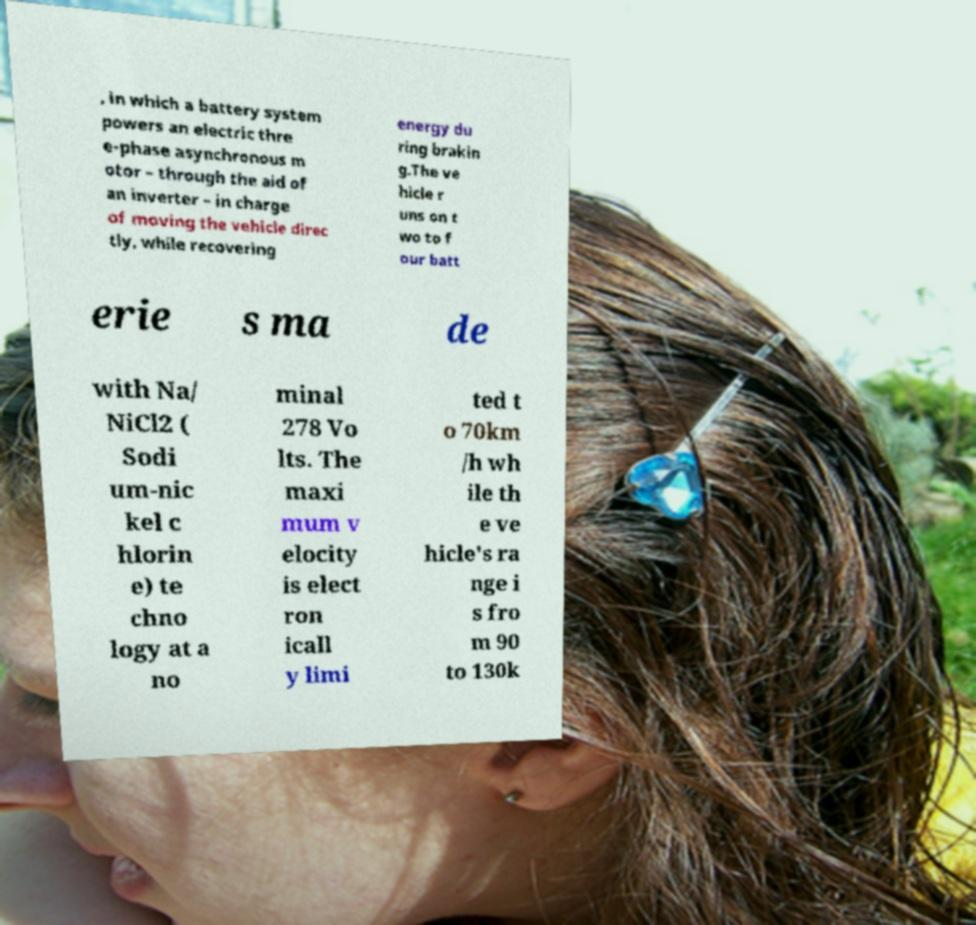There's text embedded in this image that I need extracted. Can you transcribe it verbatim? , in which a battery system powers an electric thre e-phase asynchronous m otor – through the aid of an inverter – in charge of moving the vehicle direc tly, while recovering energy du ring brakin g.The ve hicle r uns on t wo to f our batt erie s ma de with Na/ NiCl2 ( Sodi um-nic kel c hlorin e) te chno logy at a no minal 278 Vo lts. The maxi mum v elocity is elect ron icall y limi ted t o 70km /h wh ile th e ve hicle's ra nge i s fro m 90 to 130k 